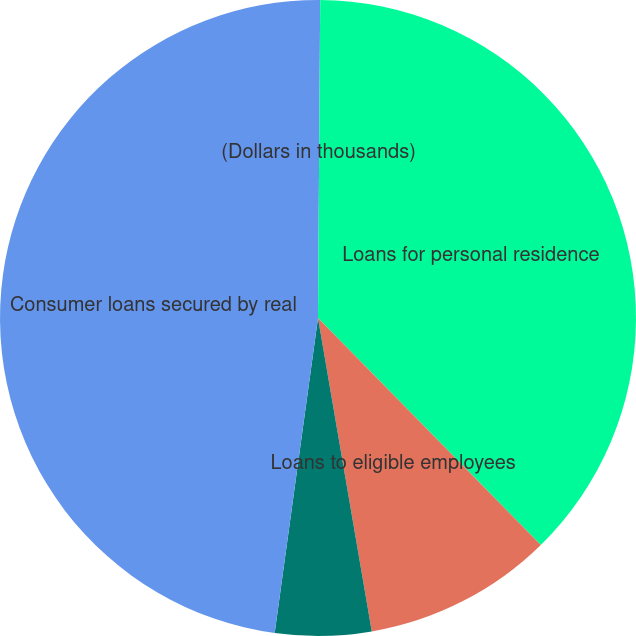Convert chart. <chart><loc_0><loc_0><loc_500><loc_500><pie_chart><fcel>(Dollars in thousands)<fcel>Loans for personal residence<fcel>Loans to eligible employees<fcel>Home equity lines of credit<fcel>Consumer loans secured by real<nl><fcel>0.11%<fcel>37.53%<fcel>9.65%<fcel>4.88%<fcel>47.82%<nl></chart> 